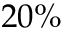Convert formula to latex. <formula><loc_0><loc_0><loc_500><loc_500>2 0 \%</formula> 